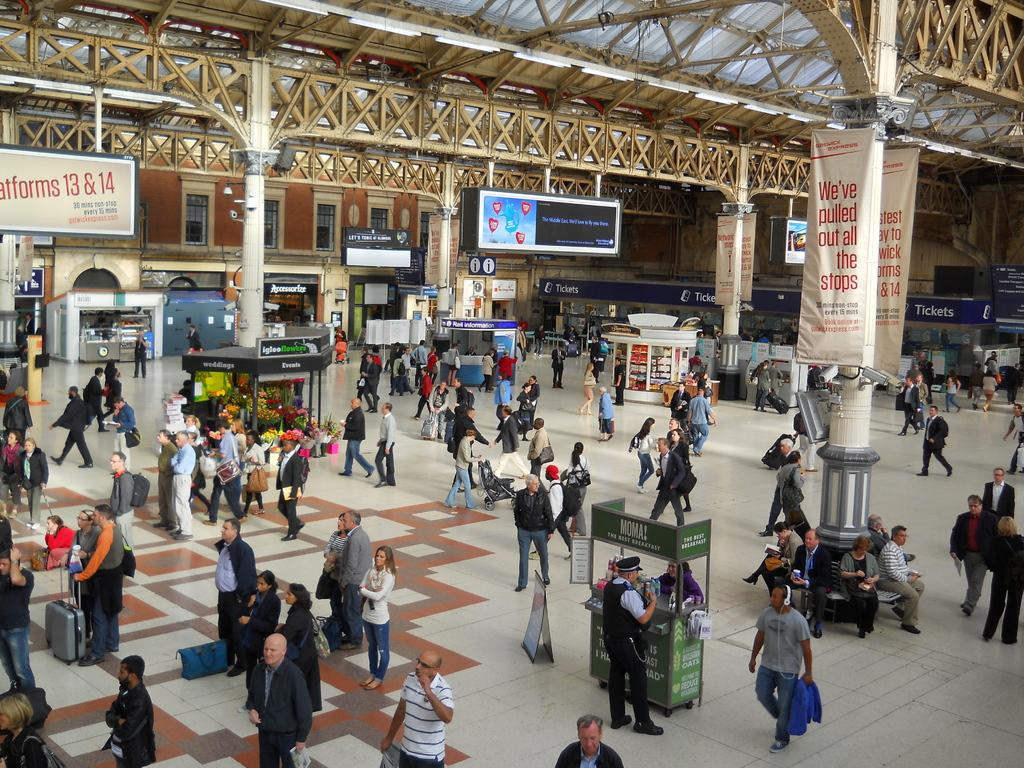<image>
Summarize the visual content of the image. A transportation station is shown, with ticket booths in the back and banners for gatwickexpress.com on the columns. 